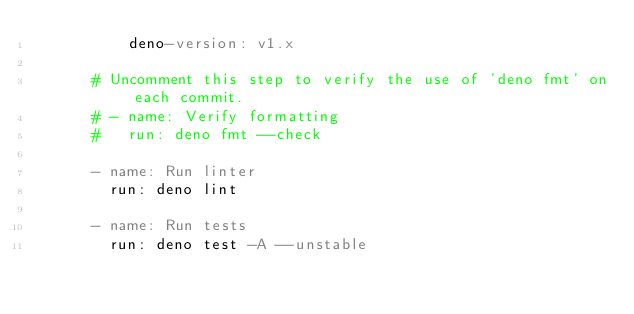Convert code to text. <code><loc_0><loc_0><loc_500><loc_500><_YAML_>          deno-version: v1.x

      # Uncomment this step to verify the use of 'deno fmt' on each commit.
      # - name: Verify formatting
      #   run: deno fmt --check

      - name: Run linter
        run: deno lint

      - name: Run tests
        run: deno test -A --unstable
</code> 